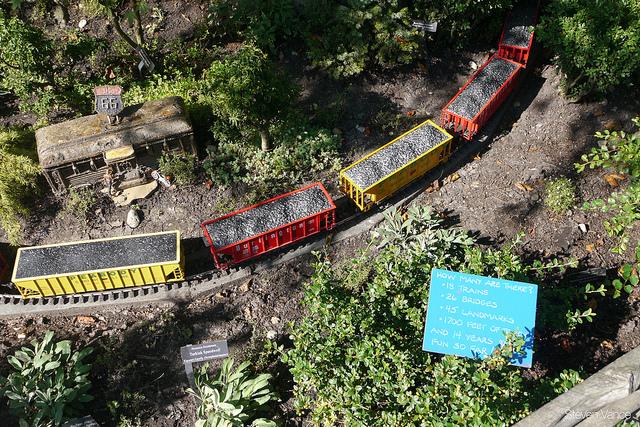How many humans could ride on this train?
Quick response, please. 0. How many train cars are there?
Quick response, please. 5. The black and white sign next to the plant suggests that this is part of what kind of display?
Answer briefly. Model train. 